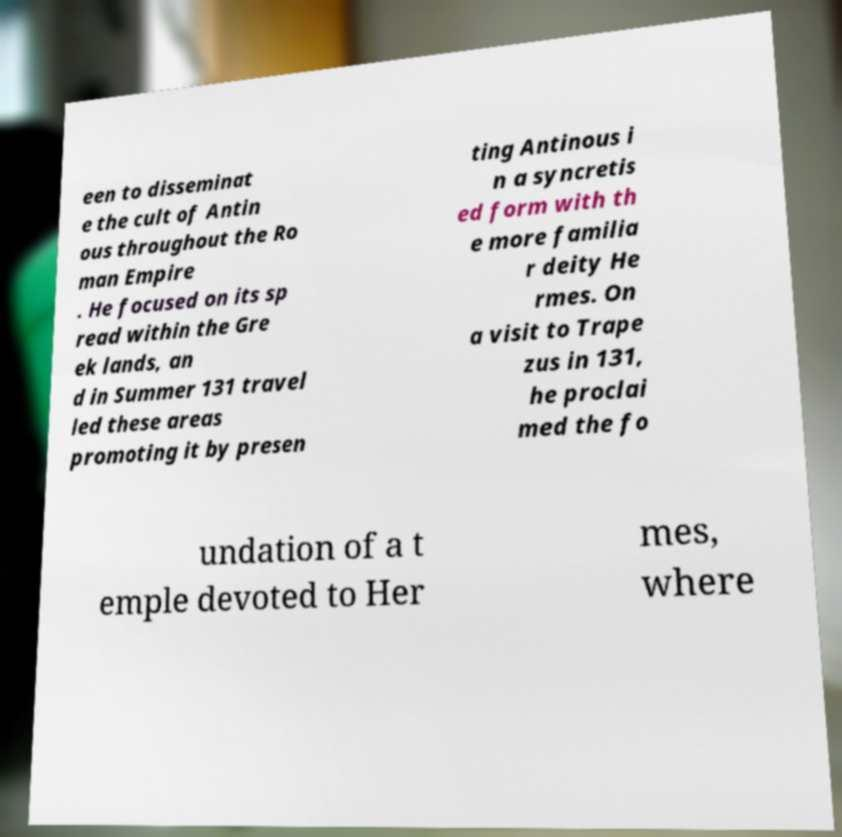Could you extract and type out the text from this image? een to disseminat e the cult of Antin ous throughout the Ro man Empire . He focused on its sp read within the Gre ek lands, an d in Summer 131 travel led these areas promoting it by presen ting Antinous i n a syncretis ed form with th e more familia r deity He rmes. On a visit to Trape zus in 131, he proclai med the fo undation of a t emple devoted to Her mes, where 